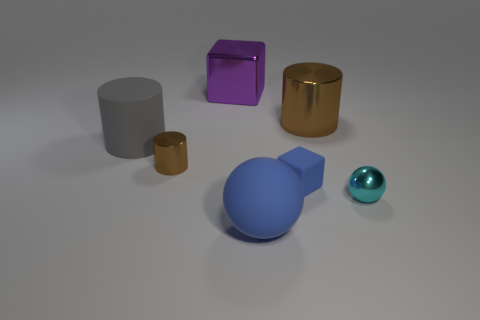Subtract all brown blocks. How many brown cylinders are left? 2 Subtract all big cylinders. How many cylinders are left? 1 Add 3 large yellow rubber objects. How many objects exist? 10 Subtract all gray cylinders. How many cylinders are left? 2 Subtract all cubes. How many objects are left? 5 Subtract all blue blocks. Subtract all blue cylinders. How many blocks are left? 1 Add 1 purple metallic cubes. How many purple metallic cubes are left? 2 Add 4 tiny matte cubes. How many tiny matte cubes exist? 5 Subtract 1 blue blocks. How many objects are left? 6 Subtract all tiny objects. Subtract all large gray metal cylinders. How many objects are left? 4 